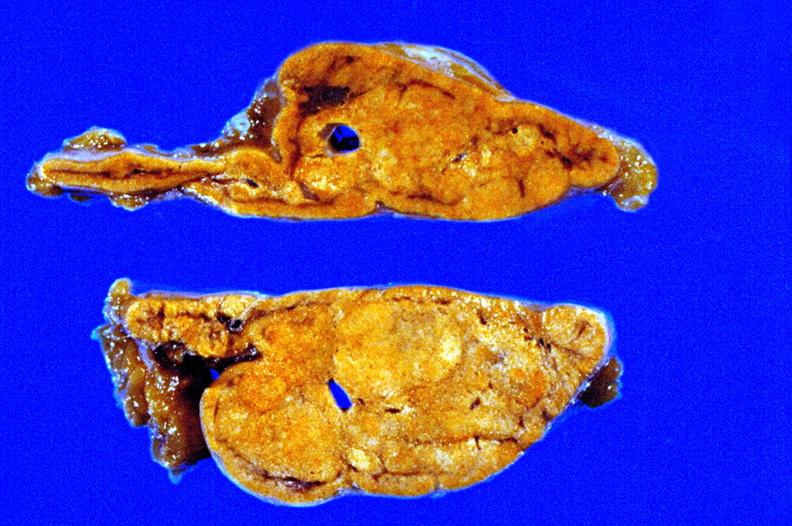s endocrine present?
Answer the question using a single word or phrase. Yes 